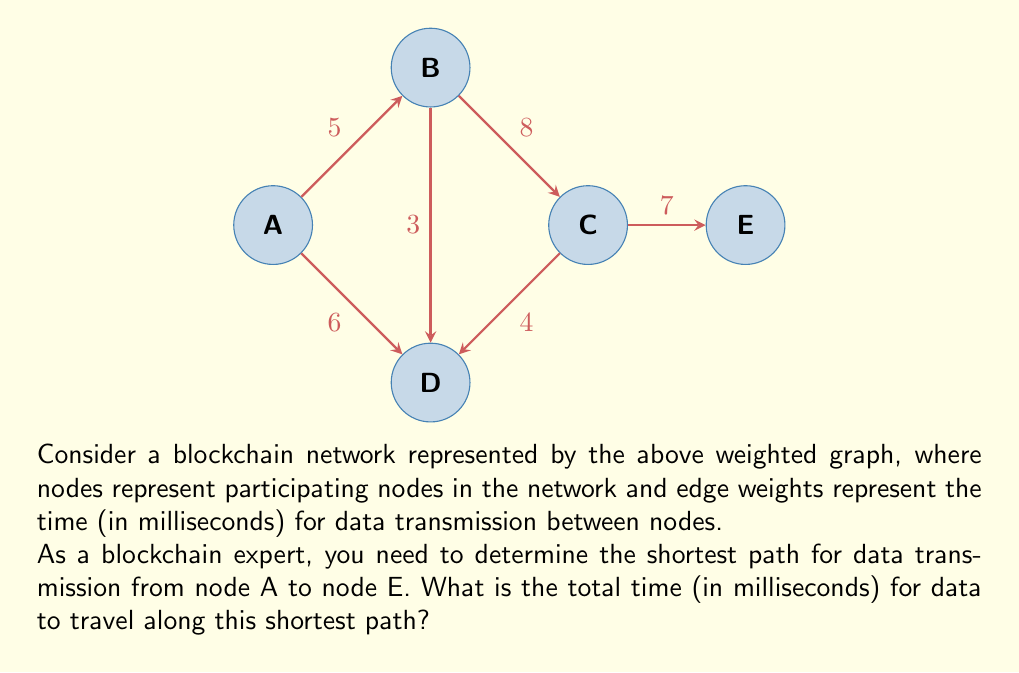Help me with this question. To solve this problem, we'll use Dijkstra's algorithm to find the shortest path from node A to node E. Let's go through the steps:

1) Initialize:
   - Distance to A: 0
   - Distance to all other nodes: $\infty$
   - Unvisited nodes: {A, B, C, D, E}

2) Start from node A:
   - Update distances: B(5), D(6)
   - Mark A as visited
   - Unvisited nodes: {B, C, D, E}

3) Select node B (shortest distance from A):
   - Update distances: C(13), D(min(6, 5+3) = 6)
   - Mark B as visited
   - Unvisited nodes: {C, D, E}

4) Select node D (shortest distance from A):
   - Update distances: C(min(13, 6+4) = 10)
   - Mark D as visited
   - Unvisited nodes: {C, E}

5) Select node C (shortest distance from A):
   - Update distances: E(10+7 = 17)
   - Mark C as visited
   - Unvisited nodes: {E}

6) Select node E (only remaining node):
   - Mark E as visited
   - Algorithm complete

The shortest path from A to E is A -> D -> C -> E with a total distance of 17 milliseconds.

Path breakdown:
A to D: 6 ms
D to C: 4 ms
C to E: 7 ms
Total: 6 + 4 + 7 = 17 ms
Answer: 17 ms 